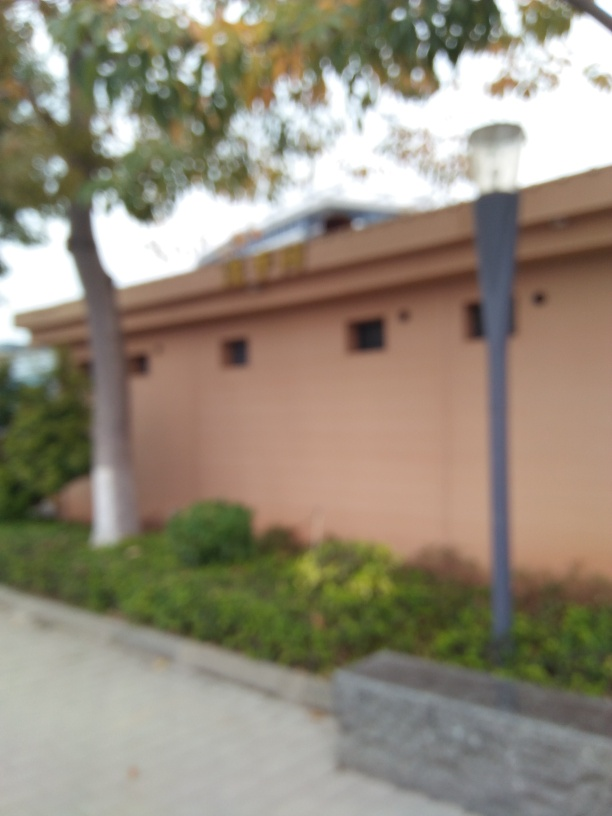What is the composition of this image like? The image appears to show an out-of-focus scene of a building, illuminated by diffuse daylight. The foreground features a sidewalk with shrubs, while the background suggests a building obscured by the shallow depth of field. There is a lamppost on the left. The overall composition could create a feeling of haziness or mystery, since details are not sharp. 